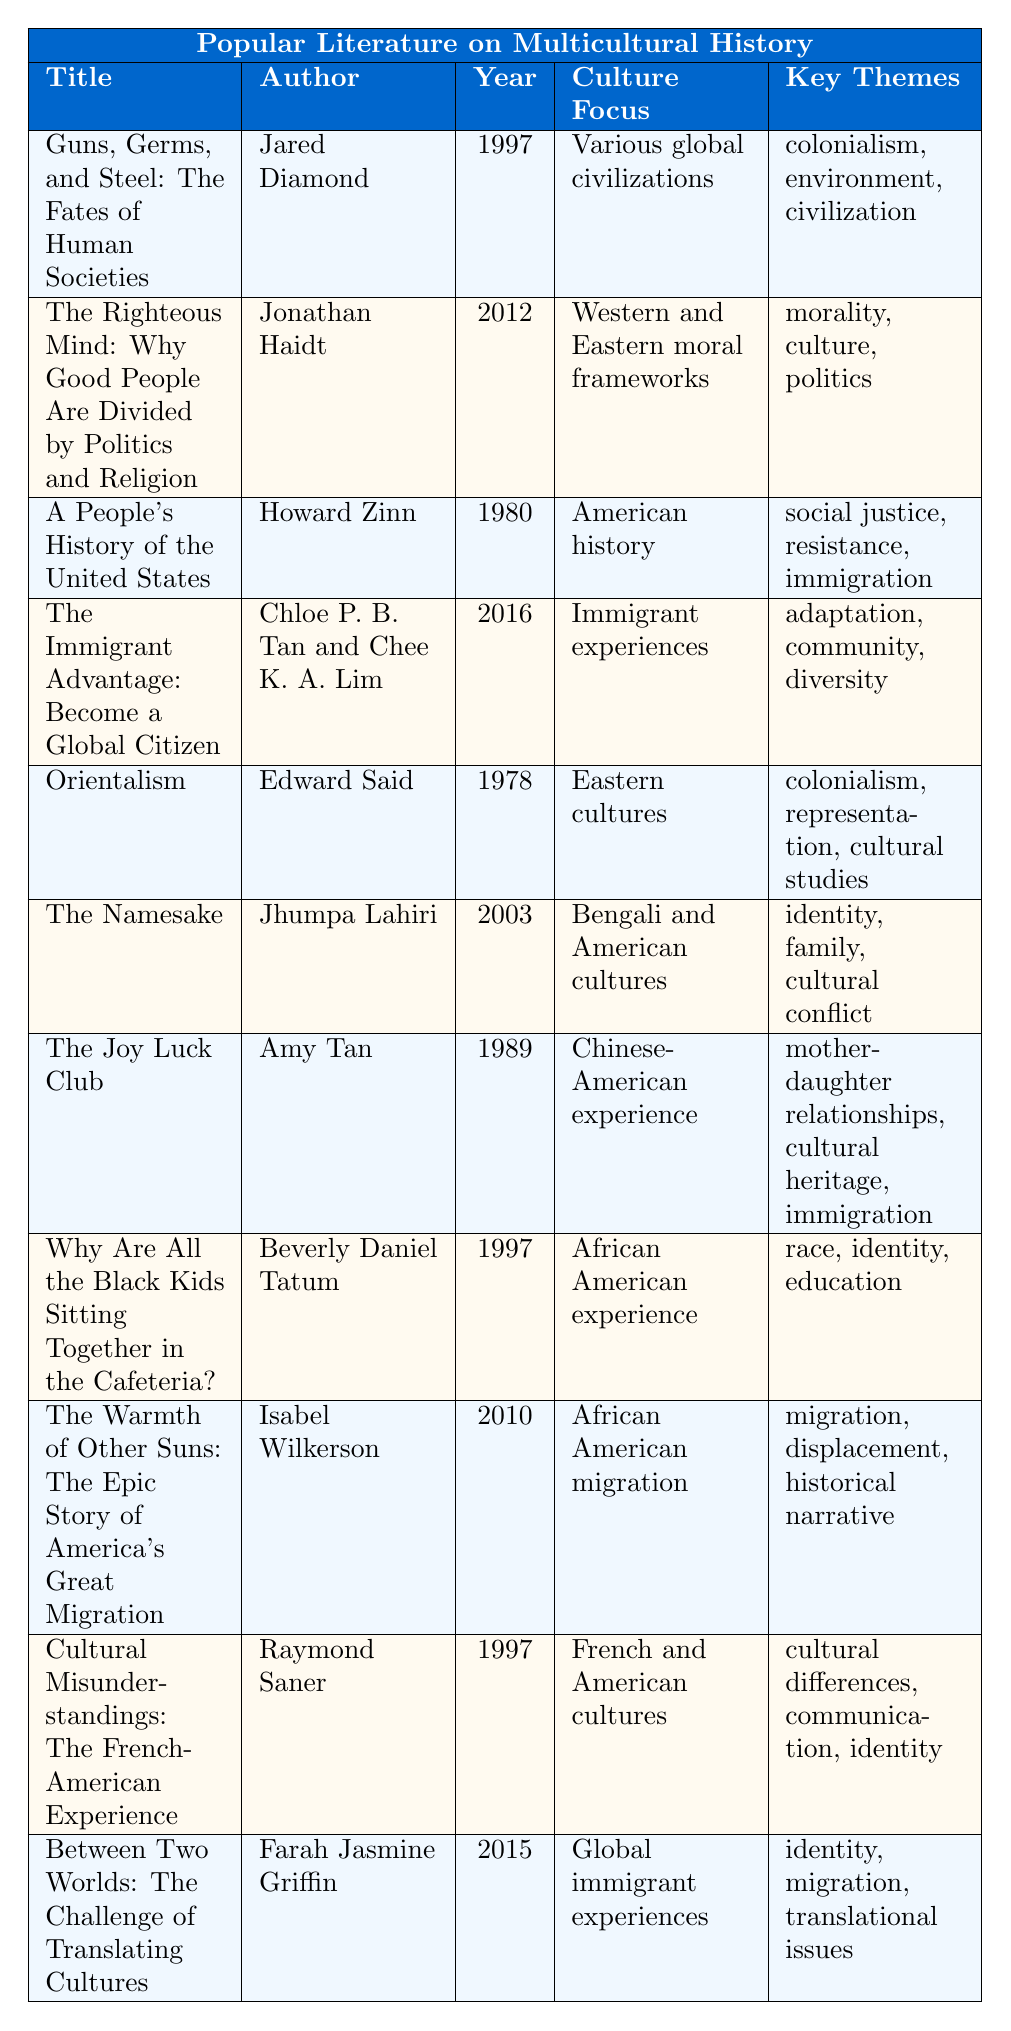What is the title of the book authored by Amy Tan? The table lists various books and their authors. By scanning the author column for "Amy Tan," I find that the title next to it is "The Joy Luck Club."
Answer: The Joy Luck Club Which book was published in 1997? In the table, I locate the year column and find two entries for 1997: "Guns, Germs, and Steel: The Fates of Human Societies" by Jared Diamond and "Why Are All the Black Kids Sitting Together in the Cafeteria?" by Beverly Daniel Tatum.
Answer: Guns, Germs, and Steel: The Fates of Human Societies and Why Are All the Black Kids Sitting Together in the Cafeteria? How many books focus on African American culture? I can count how many entries in the culture focus column mention African American culture. The two titles are: "Why Are All the Black Kids Sitting Together in the Cafeteria?" and "The Warmth of Other Suns: The Epic Story of America's Great Migration."
Answer: 2 Which book's key themes include "identity" and "migration"? Upon examining the key themes in the table, "Between Two Worlds: The Challenge of Translating Cultures" by Farah Jasmine Griffin has both "identity" and "migration" as its key themes.
Answer: Between Two Worlds: The Challenge of Translating Cultures Is "Orientalism" focused on Western cultures? The culture focus for "Orientalism" is listed as "Eastern cultures." Thus, the answer is no.
Answer: No What are the key themes of "The Joy Luck Club"? Looking at the row for "The Joy Luck Club," the key themes provided are "mother-daughter relationships," "cultural heritage," and "immigration."
Answer: mother-daughter relationships, cultural heritage, immigration List the titles of books published after 2000. By examining the publication year column, the titles of books published after 2000 are "The Namesake" (2003), "The Warmth of Other Suns: The Epic Story of America's Great Migration" (2010), and "Between Two Worlds: The Challenge of Translating Cultures" (2015).
Answer: The Namesake, The Warmth of Other Suns: The Epic Story of America's Great Migration, Between Two Worlds: The Challenge of Translating Cultures Which author wrote about the psychological basis of morality? By reviewing the author column, I see that "The Righteous Mind: Why Good People Are Divided by Politics and Religion" is authored by Jonathan Haidt, who investigates the psychological basis of morality.
Answer: Jonathan Haidt What is the common theme between "Guns, Germs, and Steel" and "Orientalism"? I check both books' key themes; "Guns, Germs, and Steel" includes "colonialism," and "Orientalism" also includes "colonialism." Therefore, they share this common theme.
Answer: Colonialism How many authors published their works in the 1990s? I look at the publication year column, finding the books by Jared Diamond (1997), Howard Zinn (1980), Amy Tan (1989), Beverly Daniel Tatum (1997), and Raymond Saner (1997). This totals five authors who published in the 1990s.
Answer: 5 